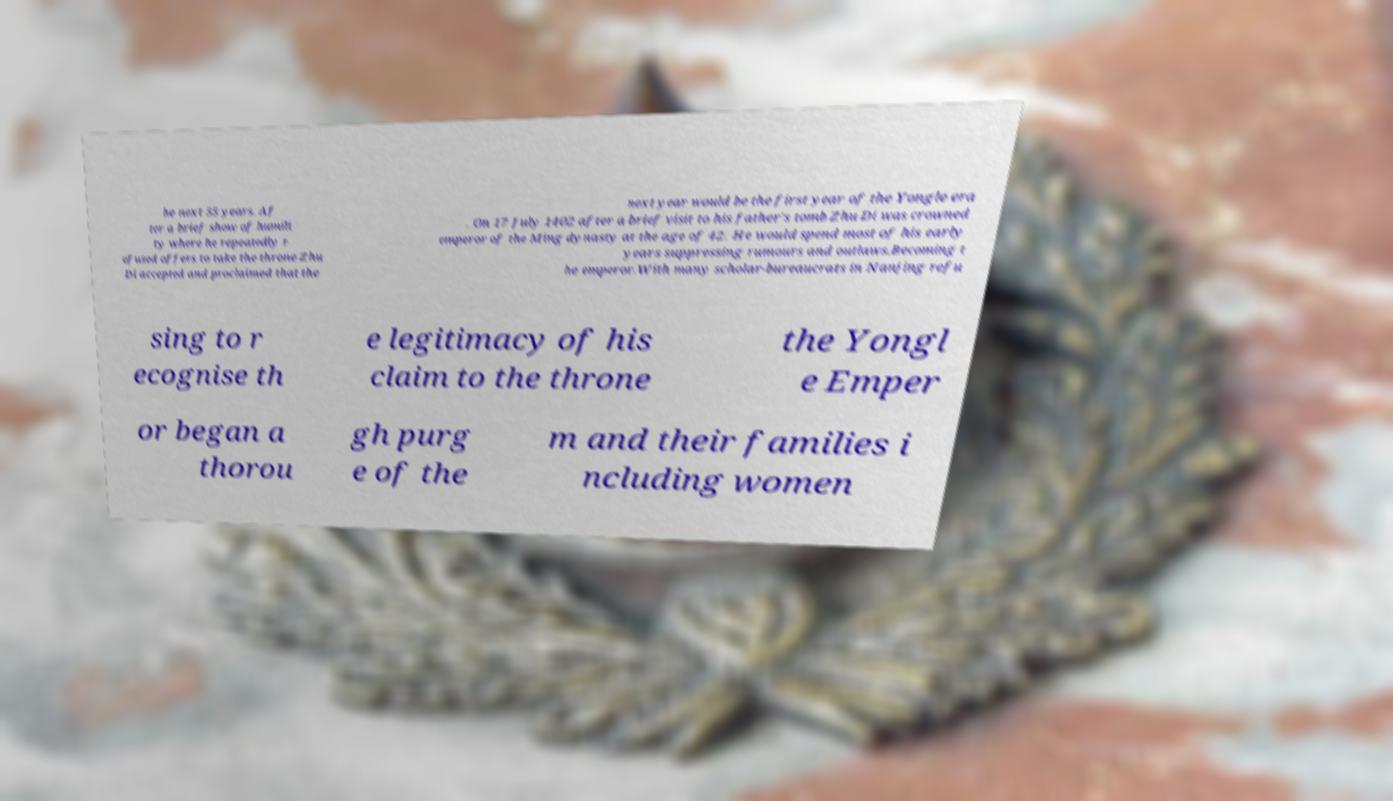Can you accurately transcribe the text from the provided image for me? he next 55 years. Af ter a brief show of humili ty where he repeatedly r efused offers to take the throne Zhu Di accepted and proclaimed that the next year would be the first year of the Yongle era . On 17 July 1402 after a brief visit to his father's tomb Zhu Di was crowned emperor of the Ming dynasty at the age of 42. He would spend most of his early years suppressing rumours and outlaws.Becoming t he emperor.With many scholar-bureaucrats in Nanjing refu sing to r ecognise th e legitimacy of his claim to the throne the Yongl e Emper or began a thorou gh purg e of the m and their families i ncluding women 